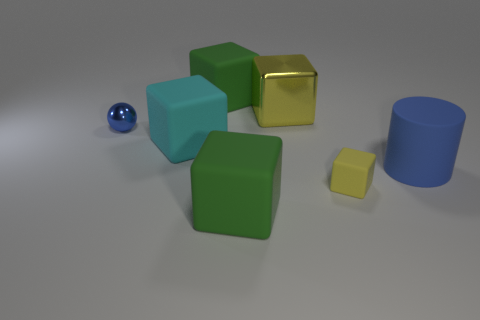There is a metal sphere; is it the same size as the yellow thing that is in front of the small metallic sphere?
Your answer should be very brief. Yes. What is the color of the metal object that is the same size as the cyan cube?
Provide a succinct answer. Yellow. The blue cylinder is what size?
Give a very brief answer. Large. Is the material of the tiny object that is behind the blue rubber cylinder the same as the big yellow object?
Provide a short and direct response. Yes. Is the shape of the large cyan rubber object the same as the tiny rubber thing?
Ensure brevity in your answer.  Yes. There is a blue thing behind the big blue matte cylinder that is in front of the green block behind the cyan matte thing; what is its shape?
Keep it short and to the point. Sphere. Do the metallic thing that is to the right of the small blue metal object and the yellow thing that is in front of the big blue cylinder have the same shape?
Your answer should be very brief. Yes. Are there any tiny balls made of the same material as the blue cylinder?
Make the answer very short. No. There is a small thing in front of the blue thing on the left side of the yellow object that is behind the cyan rubber object; what color is it?
Offer a very short reply. Yellow. Do the large green cube in front of the blue sphere and the yellow thing behind the small yellow matte thing have the same material?
Ensure brevity in your answer.  No. 